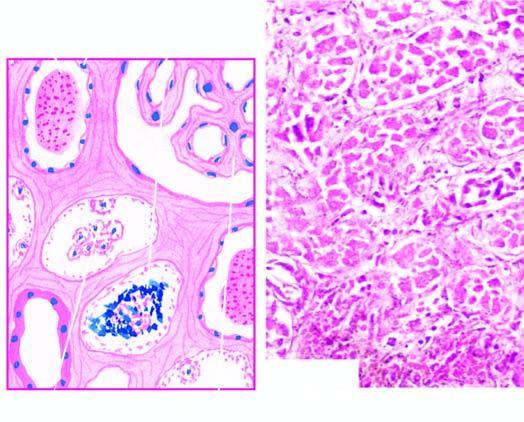does 2,3-bpg and co2 contain casts and the regenerating flat epithelium lines the necrosed tubule?
Answer the question using a single word or phrase. No 